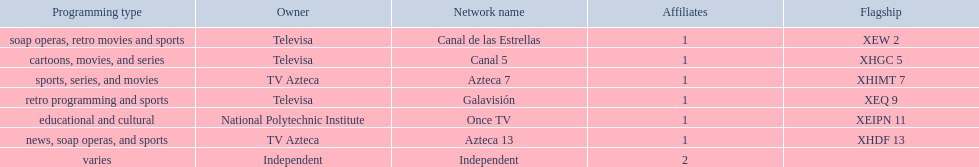What station shows cartoons? Canal 5. What station shows soap operas? Canal de las Estrellas. What station shows sports? Azteca 7. 